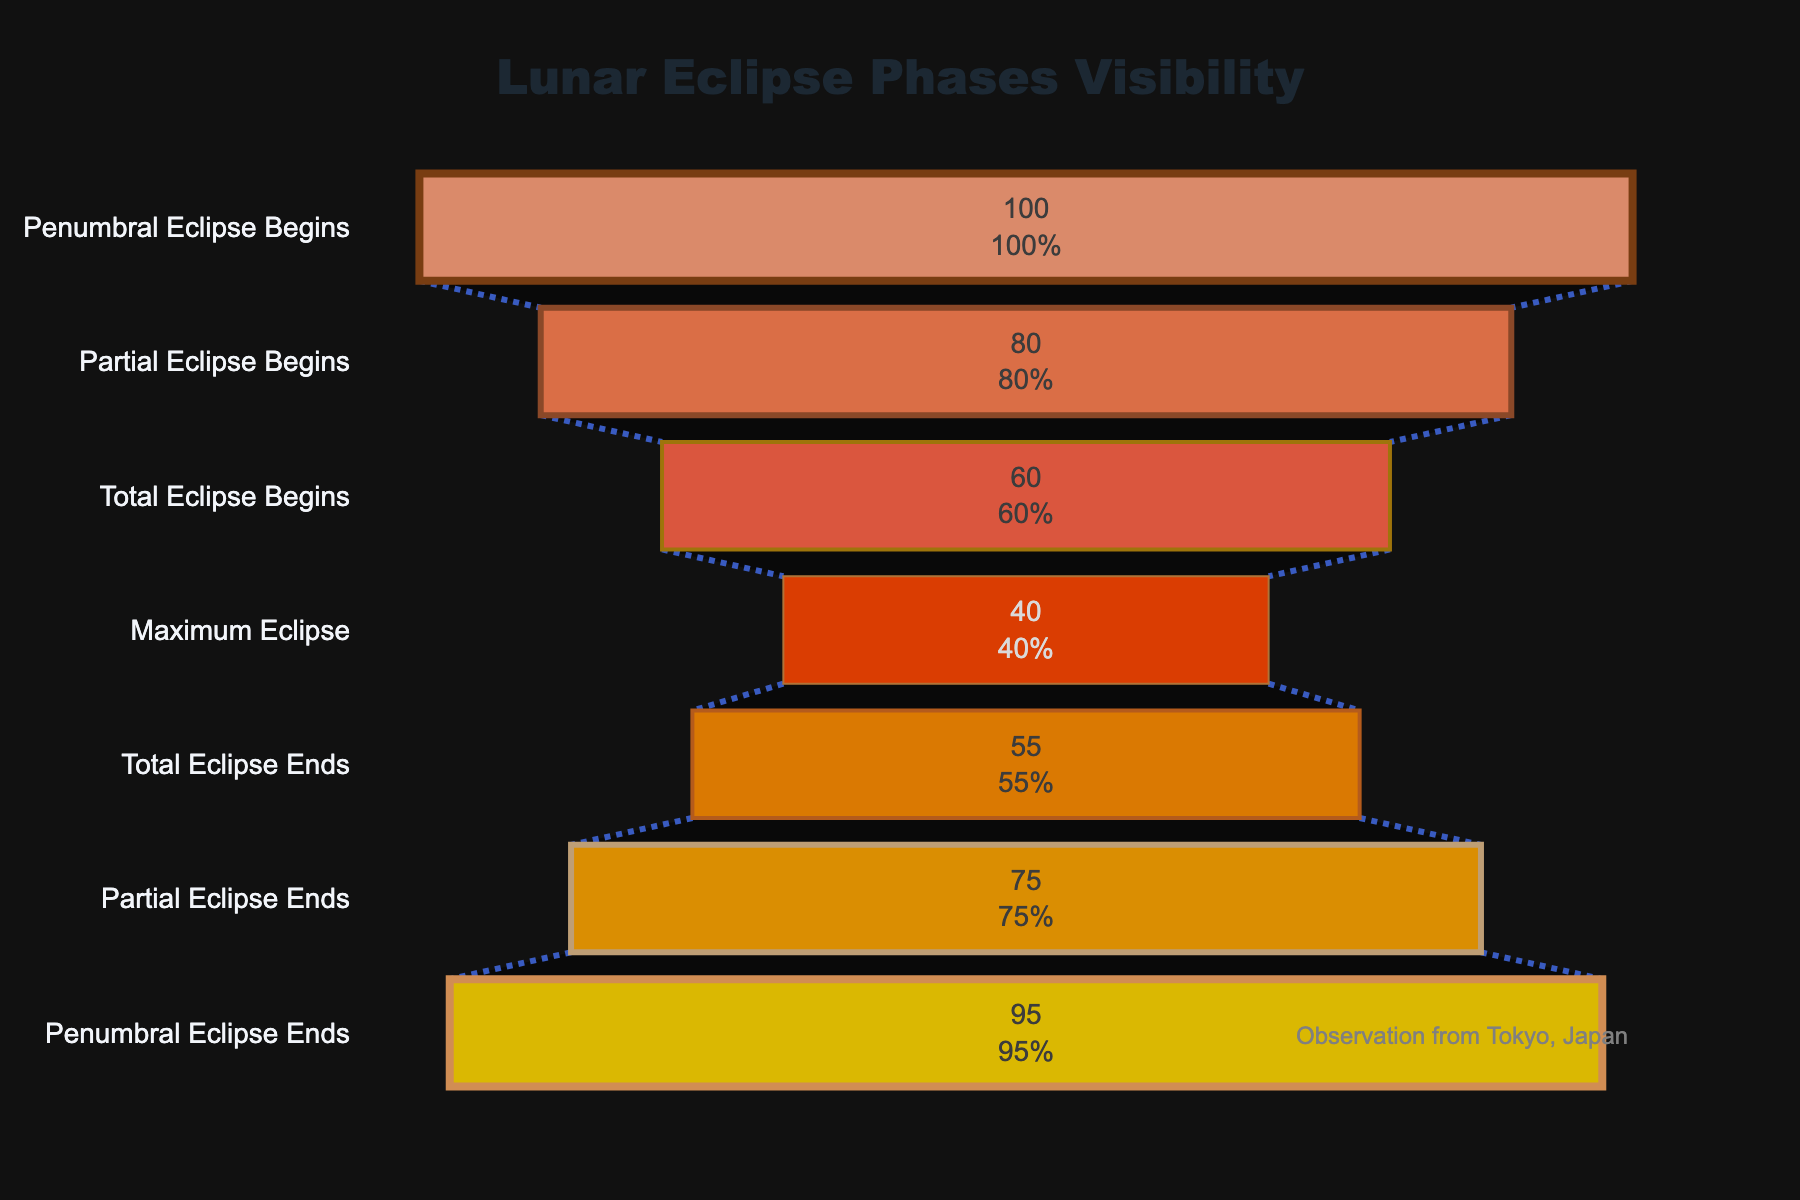What is the title of the figure? The title is typically displayed at the top center of the figure and gives an overview of what the chart represents. In this case, it informs us about the visibility of different lunar eclipse phases.
Answer: Lunar Eclipse Phases Visibility What is the visibility percentage at the stage 'Penumbral Eclipse Begins'? This refers to the percentage shown next to the stage 'Penumbral Eclipse Begins' on the funnel chart. It is usually one of the first data points listed.
Answer: 100% Which stage has the lowest visibility percentage? To find the stage with the lowest visibility, one has to locate the lowest value among the percentages listed alongside each stage in the funnel chart.
Answer: Maximum Eclipse What is the difference in visibility percentage between 'Penumbral Eclipse Begins' and 'Partial Eclipse Begins'? This involves subtracting the visibility percentage of 'Partial Eclipse Begins' from the 'Penumbral Eclipse Begins'.
Answer: 20% (100% - 80%) At which stage does the visibility percentage drop below 50%? This requires checking each stage in sequential order to identify where the percentage first falls below 50%.
Answer: Maximum Eclipse How many stages show an increase in visibility percentage after 'Maximum Eclipse'? Count the number of stages following 'Maximum Eclipse' where the visibility percentage is higher than the preceding stage.
Answer: 2 stages (Total Eclipse Ends, Partial Eclipse Ends) Compare the visibility percentages of 'Total Eclipse Begins' and 'Total Eclipse Ends': which one is higher? This involves directly comparing the visibility percentage values at these two stages.
Answer: Total Eclipse Ends What is the average visibility percentage of all stages? Add up all visibility percentages and divide by the total number of stages: (100 + 80 + 60 + 40 + 55 + 75 + 95) / 7
Answer: 72.14% How much does the visibility percentage increase from 'Maximum Eclipse' to 'Total Eclipse Ends'? Subtract the visibility percentage of 'Maximum Eclipse' from that of 'Total Eclipse Ends'.
Answer: 15% (55% - 40%) Identify all stages that have a visibility percentage above 70%. Look through each stage and list those with a visibility percentage greater than 70%.
Answer: Penumbral Eclipse Begins, Partial Eclipse Begins, Partial Eclipse Ends, Penumbral Eclipse Ends 